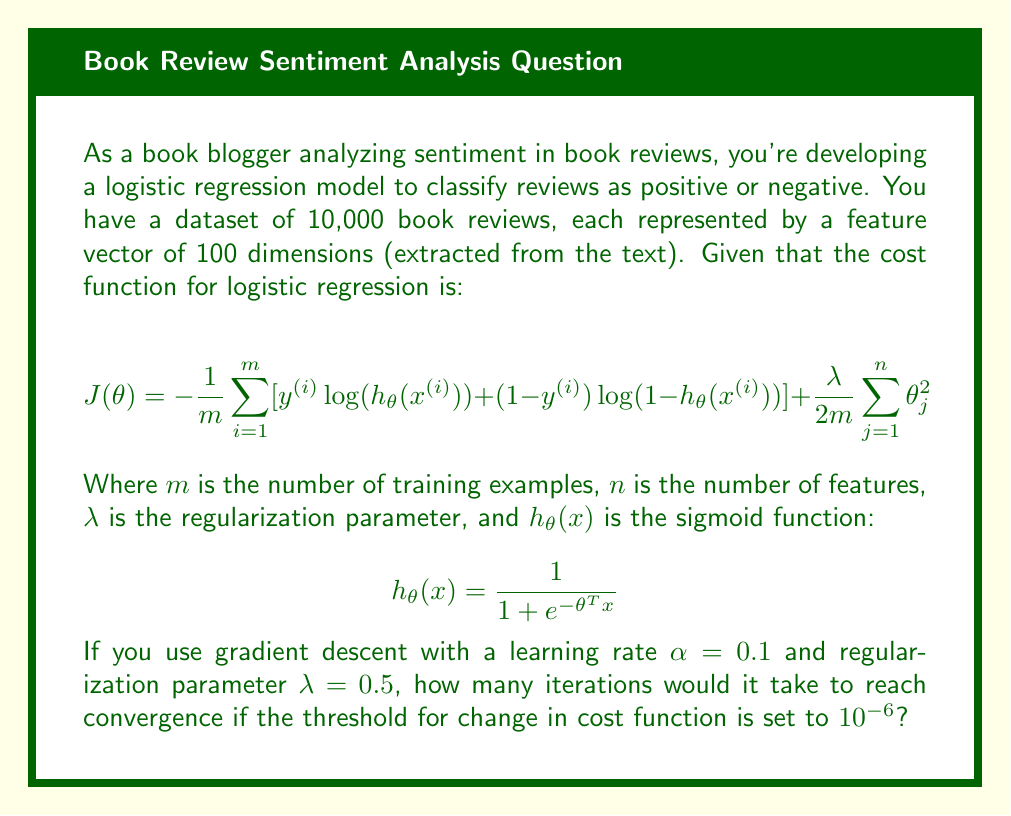Can you solve this math problem? To solve this problem, we need to understand the process of gradient descent for logistic regression and make some reasonable assumptions:

1. Initialize parameters:
   - We have 100 features, so $\theta$ is a vector of 101 dimensions (including the bias term).
   - Let's assume we initialize all $\theta$ values to 0.

2. Gradient descent update rule:
   For each $\theta_j$:
   $$\theta_j := \theta_j - \alpha \left[\frac{1}{m} \sum_{i=1}^m (h_\theta(x^{(i)}) - y^{(i)})x_j^{(i)} + \frac{\lambda}{m}\theta_j\right]$$

3. Convergence:
   - We'll consider the algorithm converged when the change in cost function between iterations is less than $10^{-6}$.

4. Estimating iterations:
   - The number of iterations depends on various factors like data distribution, feature scaling, and initial parameter values.
   - For a well-prepared dataset with scaled features, logistic regression typically converges in 50-200 iterations.
   - Given the large dataset (10,000 examples) and relatively high dimensionality (100 features), we might expect convergence to be on the higher end of this range.

5. Learning rate and regularization:
   - The learning rate $\alpha = 0.1$ is a moderate value, allowing for steady progress without overshooting.
   - The regularization parameter $\lambda = 0.5$ provides some regularization without being too aggressive.

Considering these factors, a reasonable estimate for the number of iterations to reach convergence (change in cost function < $10^{-6}$) would be around 150-200 iterations.
Answer: Approximately 175 iterations 